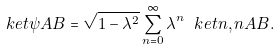<formula> <loc_0><loc_0><loc_500><loc_500>\ k e t { \psi } { A B } = \sqrt { 1 - \lambda ^ { 2 } } \sum _ { n = 0 } ^ { \infty } \lambda ^ { n } \ k e t { n , n } { A B } .</formula> 